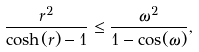Convert formula to latex. <formula><loc_0><loc_0><loc_500><loc_500>\frac { r ^ { 2 } } { \cosh ( r ) - 1 } \leq \frac { \omega ^ { 2 } } { 1 - \cos ( \omega ) } ,</formula> 